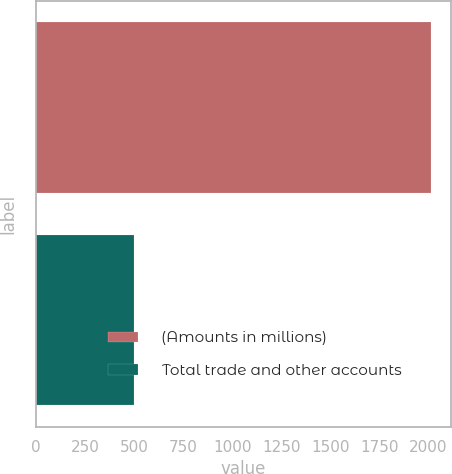<chart> <loc_0><loc_0><loc_500><loc_500><bar_chart><fcel>(Amounts in millions)<fcel>Total trade and other accounts<nl><fcel>2012<fcel>497.9<nl></chart> 